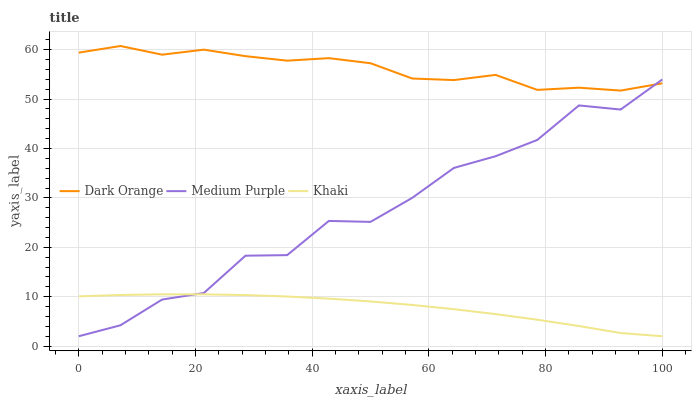Does Khaki have the minimum area under the curve?
Answer yes or no. Yes. Does Dark Orange have the maximum area under the curve?
Answer yes or no. Yes. Does Dark Orange have the minimum area under the curve?
Answer yes or no. No. Does Khaki have the maximum area under the curve?
Answer yes or no. No. Is Khaki the smoothest?
Answer yes or no. Yes. Is Medium Purple the roughest?
Answer yes or no. Yes. Is Dark Orange the smoothest?
Answer yes or no. No. Is Dark Orange the roughest?
Answer yes or no. No. Does Dark Orange have the lowest value?
Answer yes or no. No. Does Dark Orange have the highest value?
Answer yes or no. Yes. Does Khaki have the highest value?
Answer yes or no. No. Is Khaki less than Dark Orange?
Answer yes or no. Yes. Is Dark Orange greater than Khaki?
Answer yes or no. Yes. Does Khaki intersect Dark Orange?
Answer yes or no. No. 